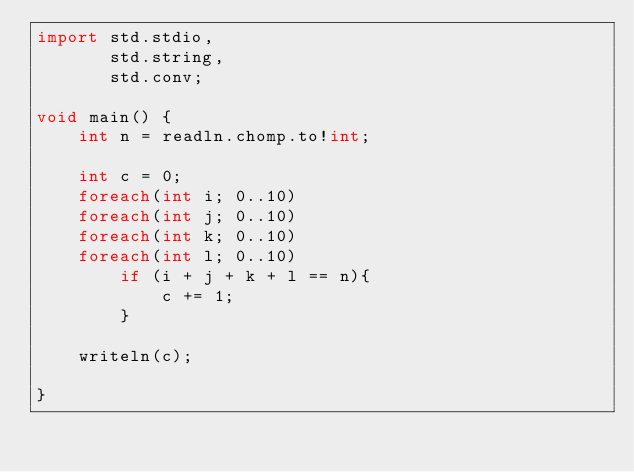<code> <loc_0><loc_0><loc_500><loc_500><_D_>import std.stdio,
	   std.string,
	   std.conv;

void main() {
	int n = readln.chomp.to!int;

	int c = 0;
	foreach(int i; 0..10)
	foreach(int j; 0..10)
	foreach(int k; 0..10)
	foreach(int l; 0..10)
		if (i + j + k + l == n){
			c += 1;
		}

	writeln(c);

}</code> 